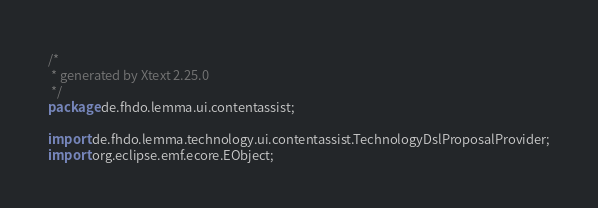Convert code to text. <code><loc_0><loc_0><loc_500><loc_500><_Java_>/*
 * generated by Xtext 2.25.0
 */
package de.fhdo.lemma.ui.contentassist;

import de.fhdo.lemma.technology.ui.contentassist.TechnologyDslProposalProvider;
import org.eclipse.emf.ecore.EObject;</code> 